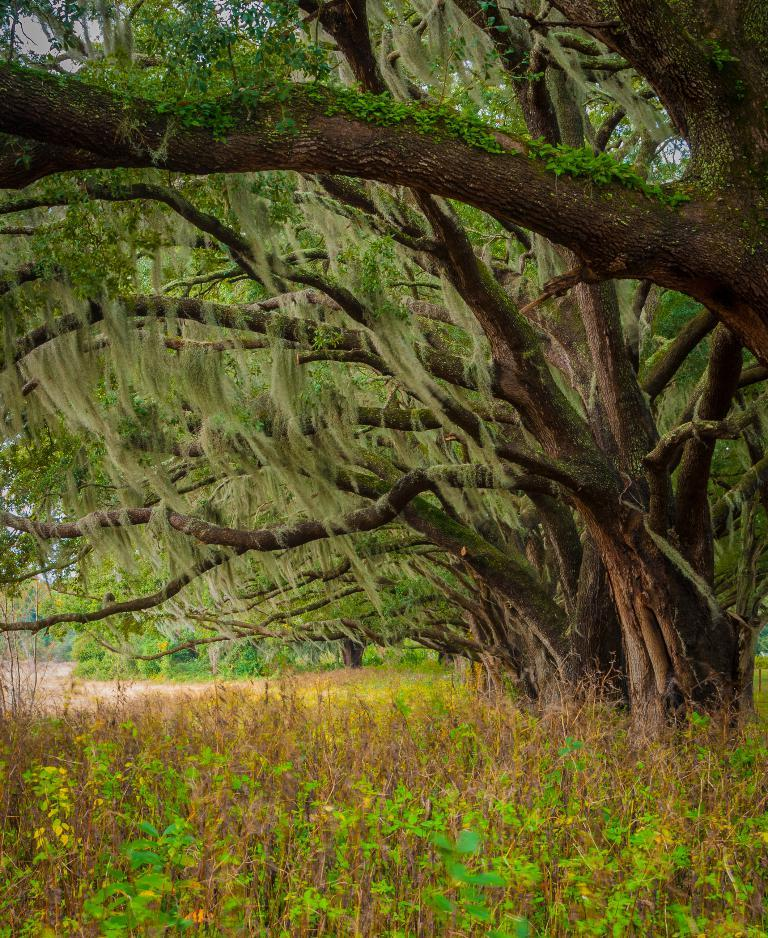What type of vegetation can be seen in the image? There are trees and plants in the image. What part of the natural environment is visible in the image? The sky is visible in the image. What type of nut is being used to climb the trees in the image? There are no nuts or climbing activities depicted in the image; it features trees and plants with the sky visible in the background. 